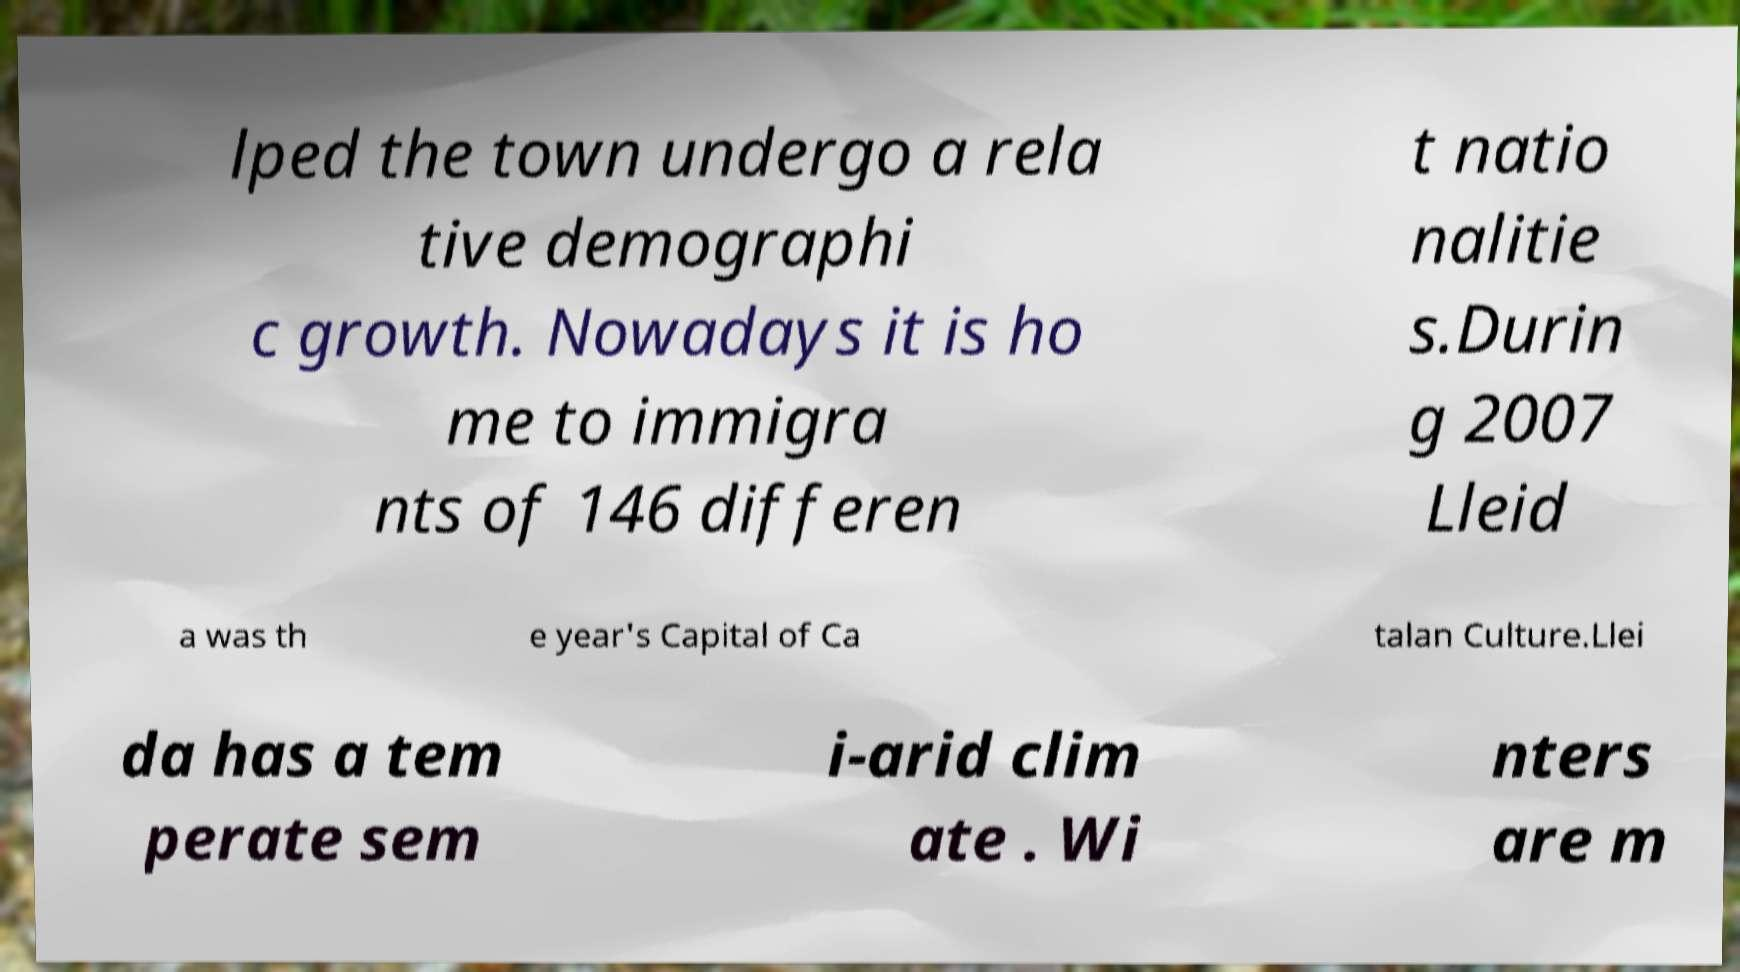Can you read and provide the text displayed in the image?This photo seems to have some interesting text. Can you extract and type it out for me? lped the town undergo a rela tive demographi c growth. Nowadays it is ho me to immigra nts of 146 differen t natio nalitie s.Durin g 2007 Lleid a was th e year's Capital of Ca talan Culture.Llei da has a tem perate sem i-arid clim ate . Wi nters are m 